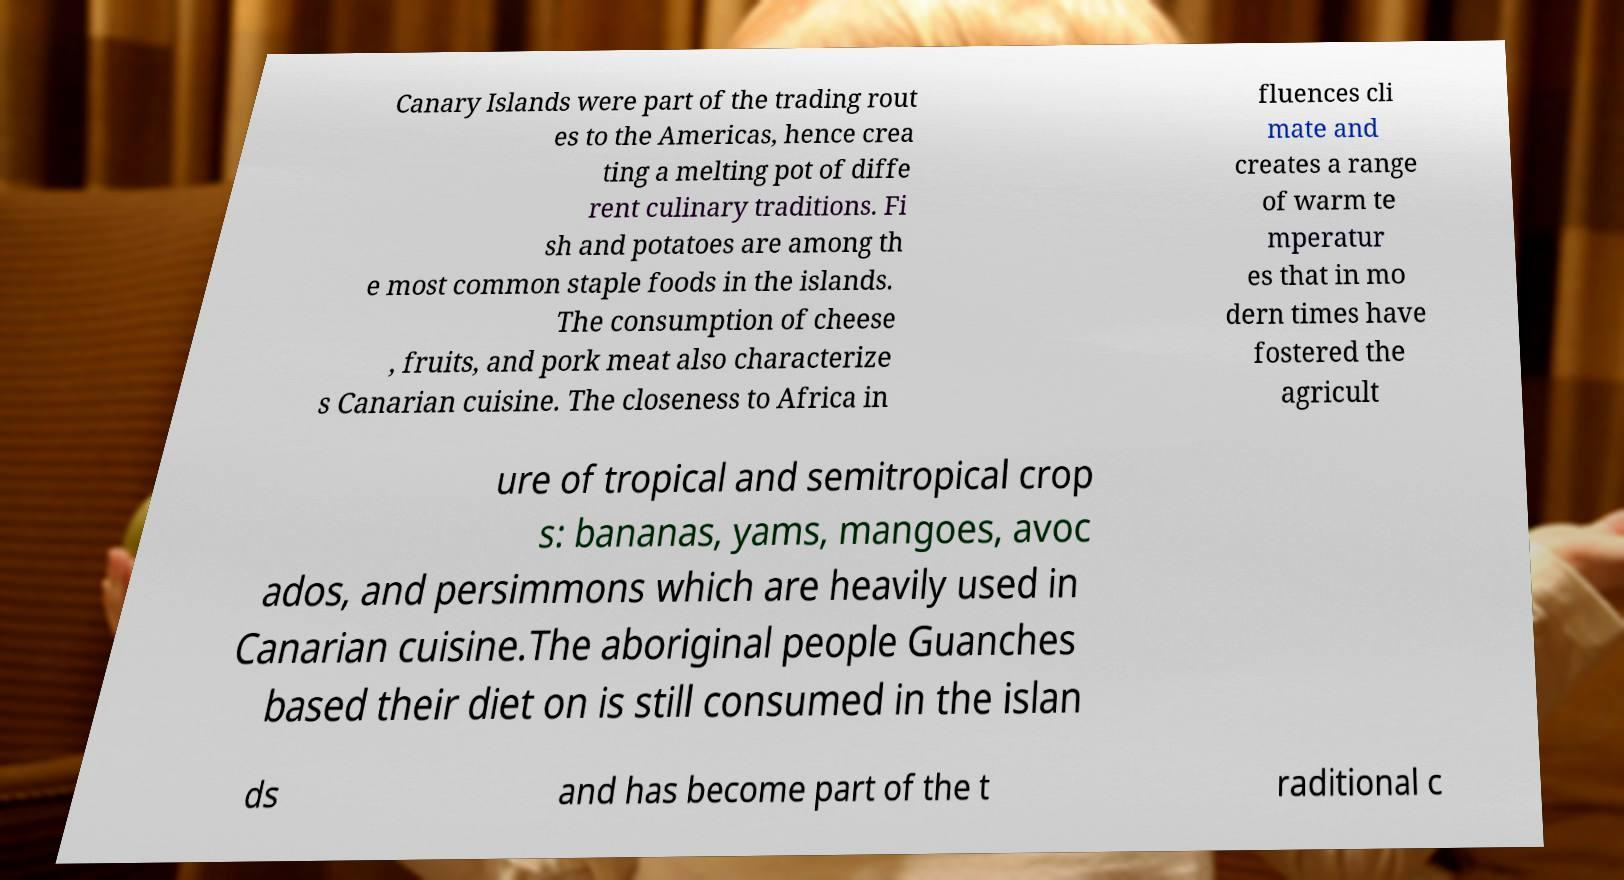There's text embedded in this image that I need extracted. Can you transcribe it verbatim? Canary Islands were part of the trading rout es to the Americas, hence crea ting a melting pot of diffe rent culinary traditions. Fi sh and potatoes are among th e most common staple foods in the islands. The consumption of cheese , fruits, and pork meat also characterize s Canarian cuisine. The closeness to Africa in fluences cli mate and creates a range of warm te mperatur es that in mo dern times have fostered the agricult ure of tropical and semitropical crop s: bananas, yams, mangoes, avoc ados, and persimmons which are heavily used in Canarian cuisine.The aboriginal people Guanches based their diet on is still consumed in the islan ds and has become part of the t raditional c 